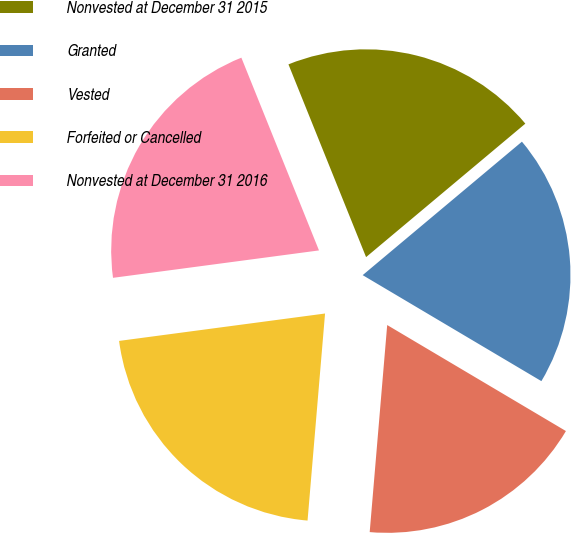Convert chart to OTSL. <chart><loc_0><loc_0><loc_500><loc_500><pie_chart><fcel>Nonvested at December 31 2015<fcel>Granted<fcel>Vested<fcel>Forfeited or Cancelled<fcel>Nonvested at December 31 2016<nl><fcel>19.99%<fcel>19.62%<fcel>17.82%<fcel>21.55%<fcel>21.01%<nl></chart> 